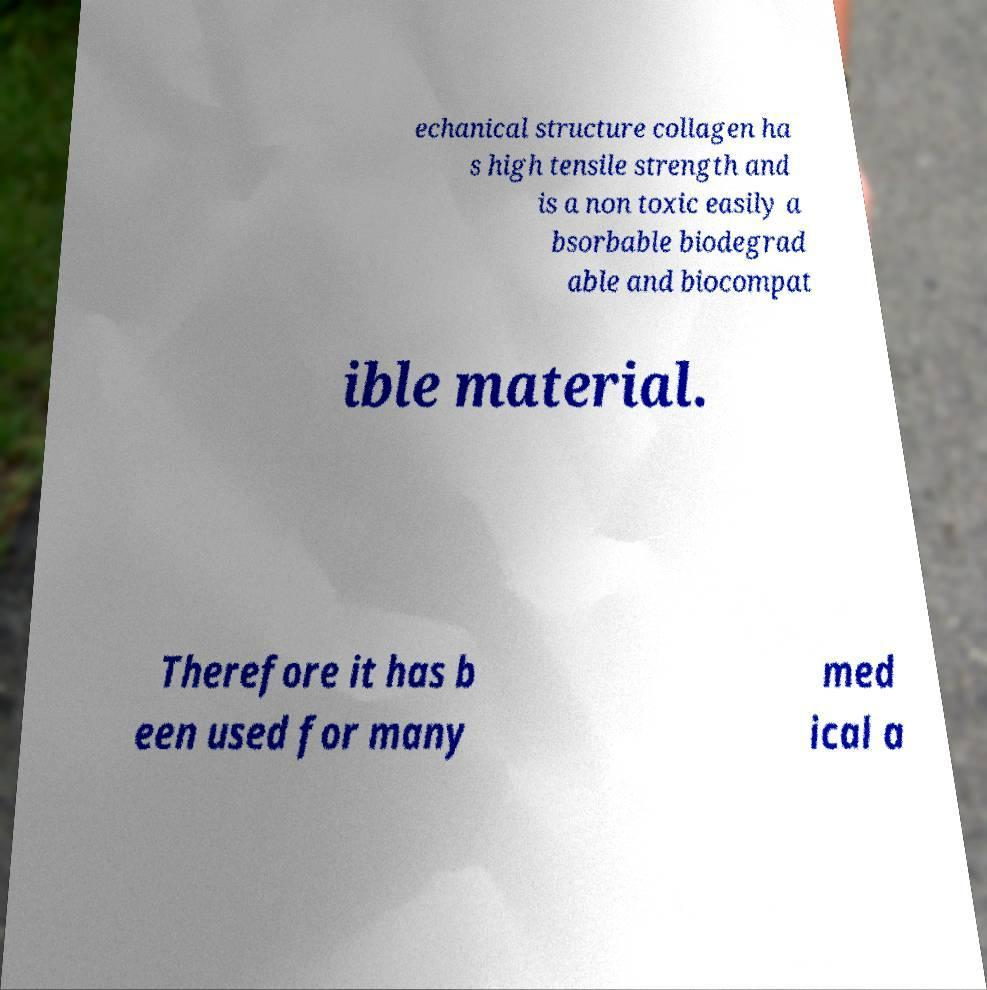Please read and relay the text visible in this image. What does it say? echanical structure collagen ha s high tensile strength and is a non toxic easily a bsorbable biodegrad able and biocompat ible material. Therefore it has b een used for many med ical a 